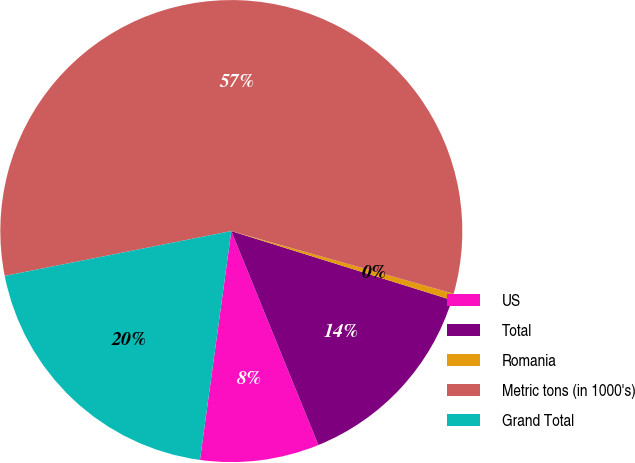Convert chart to OTSL. <chart><loc_0><loc_0><loc_500><loc_500><pie_chart><fcel>US<fcel>Total<fcel>Romania<fcel>Metric tons (in 1000's)<fcel>Grand Total<nl><fcel>8.32%<fcel>14.02%<fcel>0.46%<fcel>57.48%<fcel>19.72%<nl></chart> 